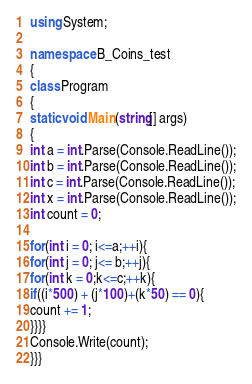Convert code to text. <code><loc_0><loc_0><loc_500><loc_500><_C#_>using System;

namespace B_Coins_test
{
class Program
{
static void Main(string[] args)
{
int a = int.Parse(Console.ReadLine());
int b = int.Parse(Console.ReadLine());
int c = int.Parse(Console.ReadLine());
int x = int.Parse(Console.ReadLine());
int count = 0;

for(int i = 0; i<=a;++i){
for(int j = 0; j<= b;++j){
for(int k = 0;k<=c;++k){
if((i*500) + (j*100)+(k*50) == 0){
count += 1;
}}}}
Console.Write(count);
}}}</code> 